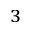Convert formula to latex. <formula><loc_0><loc_0><loc_500><loc_500>^ { 3 }</formula> 